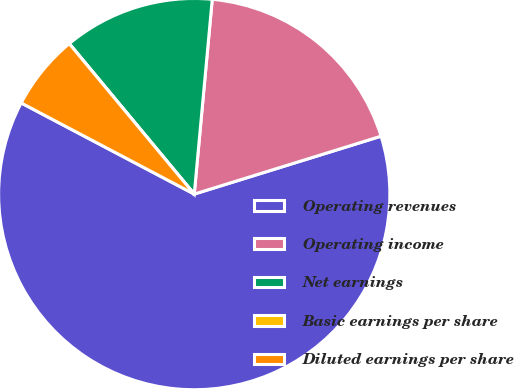Convert chart to OTSL. <chart><loc_0><loc_0><loc_500><loc_500><pie_chart><fcel>Operating revenues<fcel>Operating income<fcel>Net earnings<fcel>Basic earnings per share<fcel>Diluted earnings per share<nl><fcel>62.5%<fcel>18.75%<fcel>12.5%<fcel>0.0%<fcel>6.25%<nl></chart> 